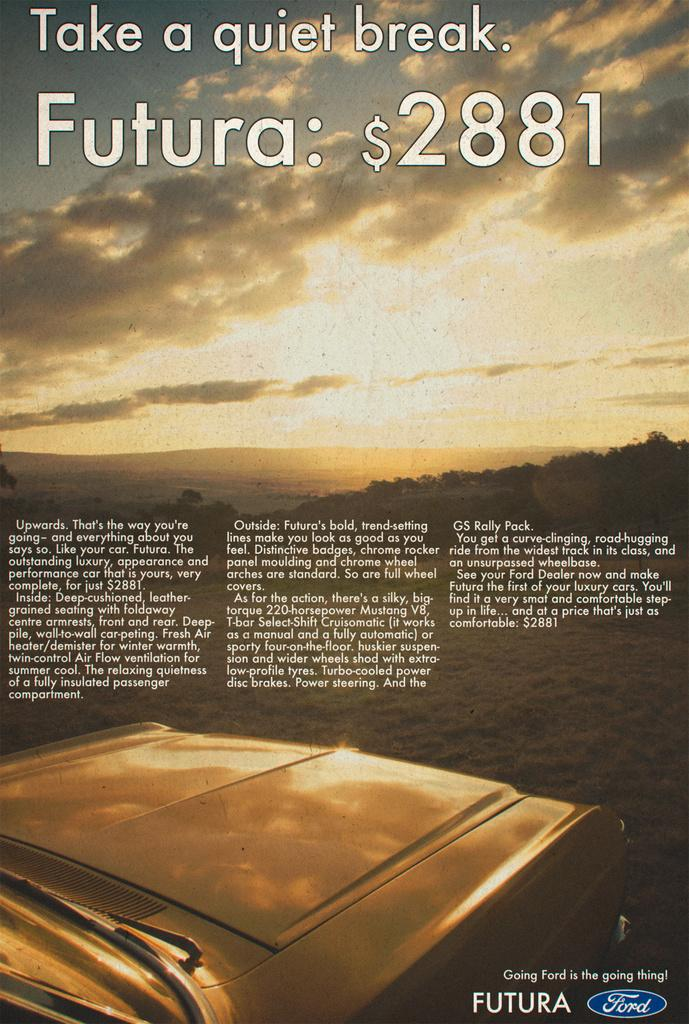<image>
Create a compact narrative representing the image presented. An ad for Ford shows an old car that costs $2881 